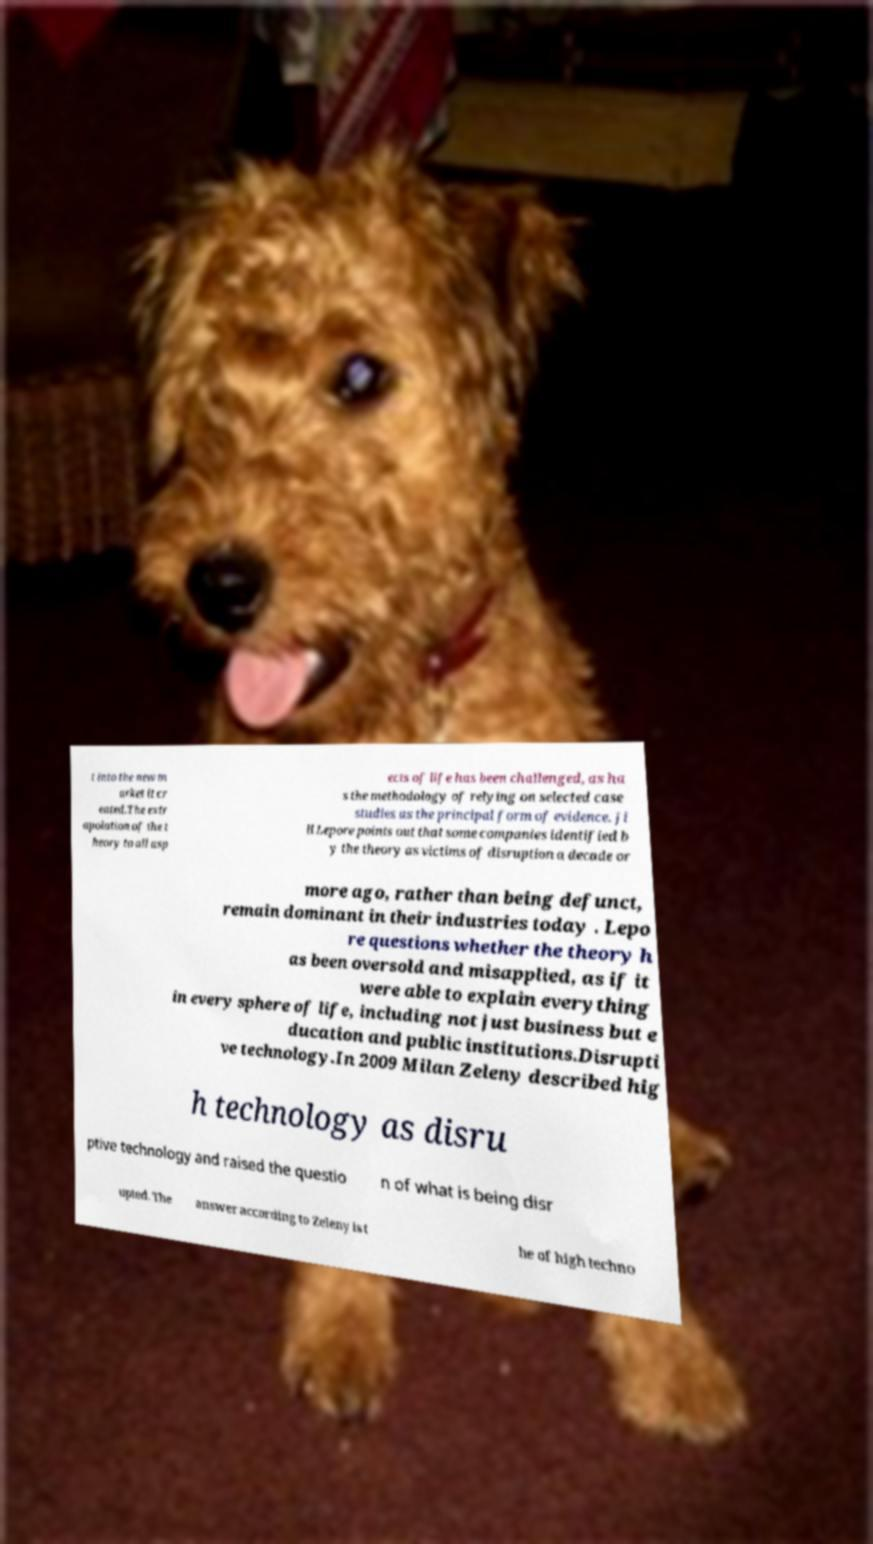Could you assist in decoding the text presented in this image and type it out clearly? t into the new m arket it cr eated.The extr apolation of the t heory to all asp ects of life has been challenged, as ha s the methodology of relying on selected case studies as the principal form of evidence. Ji ll Lepore points out that some companies identified b y the theory as victims of disruption a decade or more ago, rather than being defunct, remain dominant in their industries today . Lepo re questions whether the theory h as been oversold and misapplied, as if it were able to explain everything in every sphere of life, including not just business but e ducation and public institutions.Disrupti ve technology.In 2009 Milan Zeleny described hig h technology as disru ptive technology and raised the questio n of what is being disr upted. The answer according to Zeleny is t he of high techno 